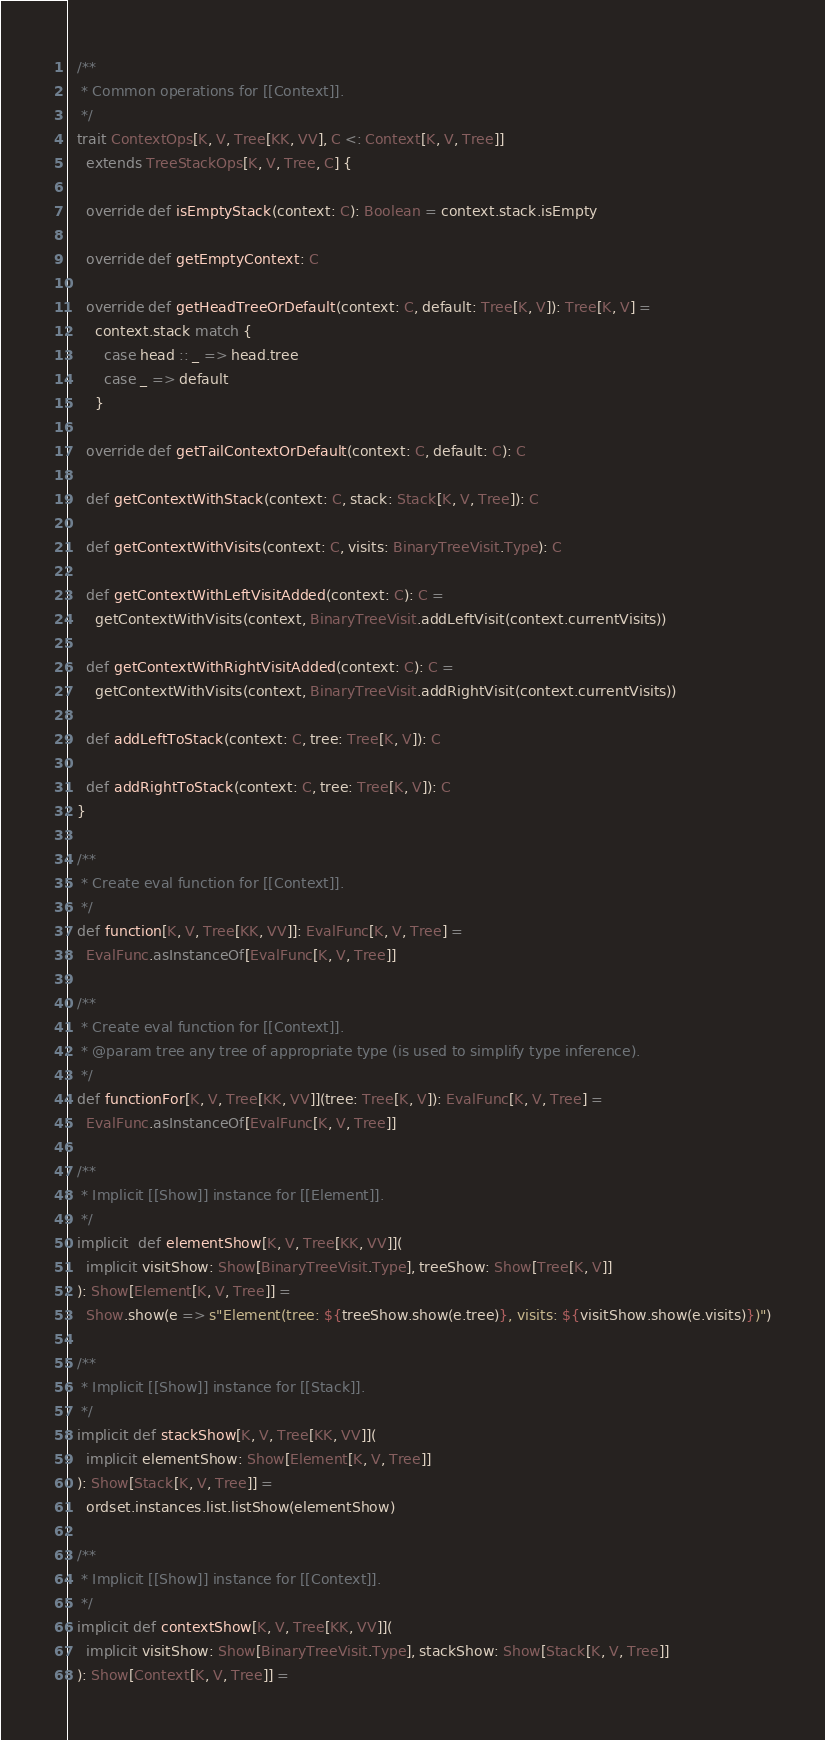Convert code to text. <code><loc_0><loc_0><loc_500><loc_500><_Scala_>
  /**
   * Common operations for [[Context]].
   */
  trait ContextOps[K, V, Tree[KK, VV], C <: Context[K, V, Tree]]
    extends TreeStackOps[K, V, Tree, C] {

    override def isEmptyStack(context: C): Boolean = context.stack.isEmpty

    override def getEmptyContext: C

    override def getHeadTreeOrDefault(context: C, default: Tree[K, V]): Tree[K, V] =
      context.stack match {
        case head :: _ => head.tree
        case _ => default
      }

    override def getTailContextOrDefault(context: C, default: C): C

    def getContextWithStack(context: C, stack: Stack[K, V, Tree]): C

    def getContextWithVisits(context: C, visits: BinaryTreeVisit.Type): C

    def getContextWithLeftVisitAdded(context: C): C =
      getContextWithVisits(context, BinaryTreeVisit.addLeftVisit(context.currentVisits))

    def getContextWithRightVisitAdded(context: C): C =
      getContextWithVisits(context, BinaryTreeVisit.addRightVisit(context.currentVisits))

    def addLeftToStack(context: C, tree: Tree[K, V]): C

    def addRightToStack(context: C, tree: Tree[K, V]): C
  }

  /**
   * Create eval function for [[Context]].
   */
  def function[K, V, Tree[KK, VV]]: EvalFunc[K, V, Tree] =
    EvalFunc.asInstanceOf[EvalFunc[K, V, Tree]]

  /**
   * Create eval function for [[Context]].
   * @param tree any tree of appropriate type (is used to simplify type inference).
   */
  def functionFor[K, V, Tree[KK, VV]](tree: Tree[K, V]): EvalFunc[K, V, Tree] =
    EvalFunc.asInstanceOf[EvalFunc[K, V, Tree]]

  /**
   * Implicit [[Show]] instance for [[Element]].
   */
  implicit  def elementShow[K, V, Tree[KK, VV]](
    implicit visitShow: Show[BinaryTreeVisit.Type], treeShow: Show[Tree[K, V]]
  ): Show[Element[K, V, Tree]] =
    Show.show(e => s"Element(tree: ${treeShow.show(e.tree)}, visits: ${visitShow.show(e.visits)})")

  /**
   * Implicit [[Show]] instance for [[Stack]].
   */
  implicit def stackShow[K, V, Tree[KK, VV]](
    implicit elementShow: Show[Element[K, V, Tree]]
  ): Show[Stack[K, V, Tree]] =
    ordset.instances.list.listShow(elementShow)

  /**
   * Implicit [[Show]] instance for [[Context]].
   */
  implicit def contextShow[K, V, Tree[KK, VV]](
    implicit visitShow: Show[BinaryTreeVisit.Type], stackShow: Show[Stack[K, V, Tree]]
  ): Show[Context[K, V, Tree]] =</code> 